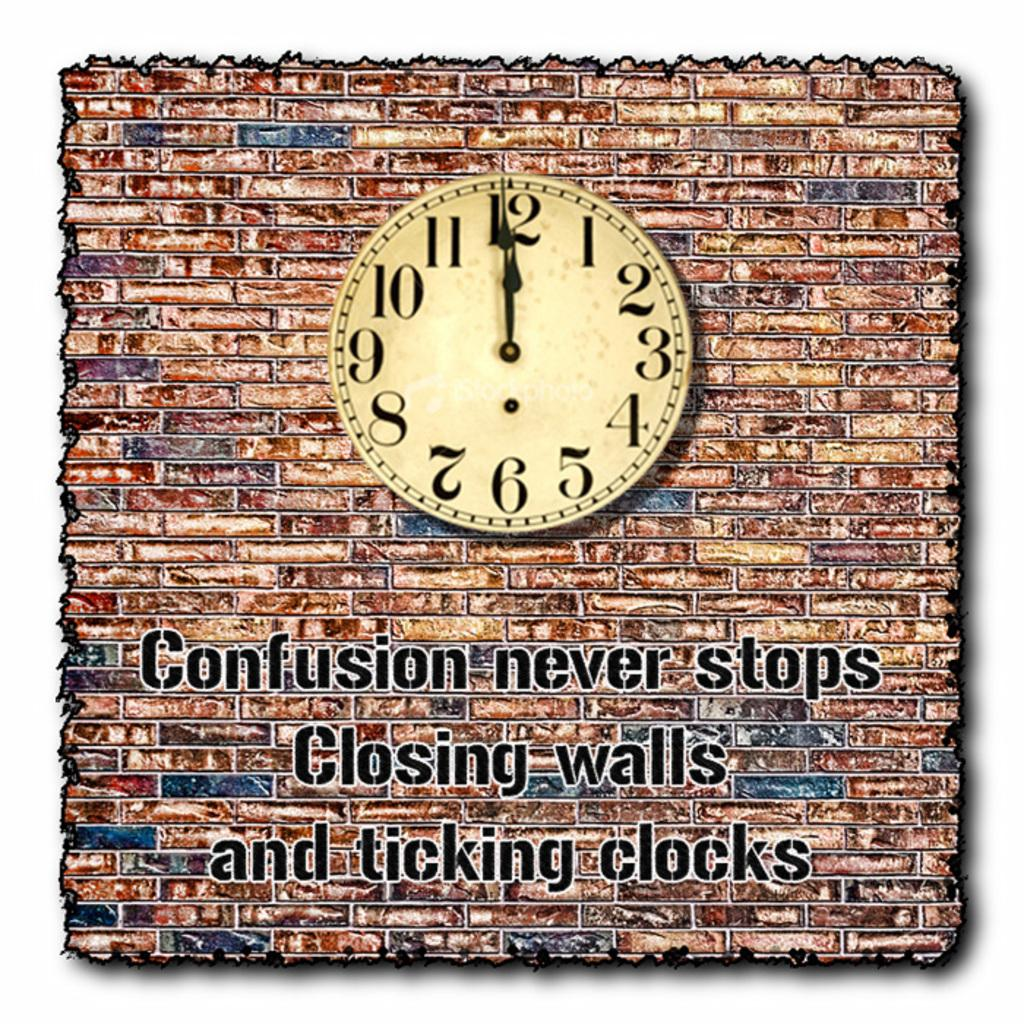<image>
Summarize the visual content of the image. a clock with regular numbers and the word confusion below 